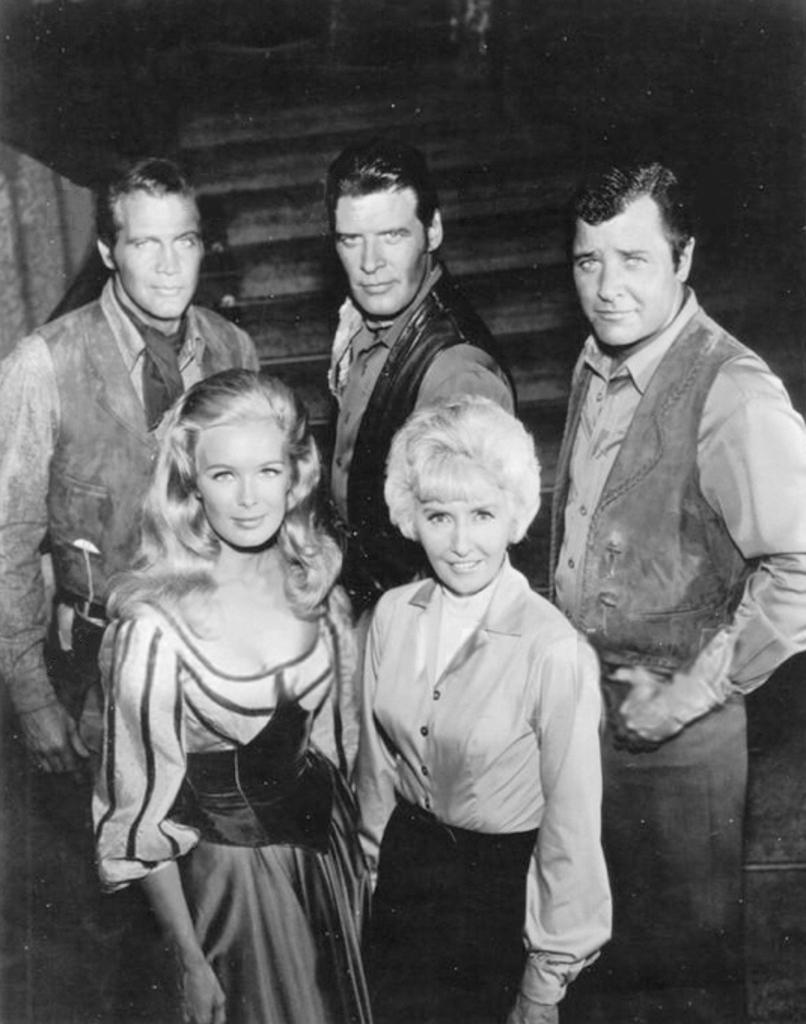How many individuals are present in the image? There is a group of people in the image. What are the people in the image doing? The people are standing. What type of jam is being spread on the clocks in the image? There is no jam or clocks present in the image; it only features a group of people standing. 